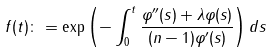<formula> <loc_0><loc_0><loc_500><loc_500>f ( t ) \colon = \exp \left ( - \int _ { 0 } ^ { t } \frac { \varphi ^ { \prime \prime } ( s ) + \lambda \varphi ( s ) } { ( n - 1 ) \varphi ^ { \prime } ( s ) } \right ) d s</formula> 